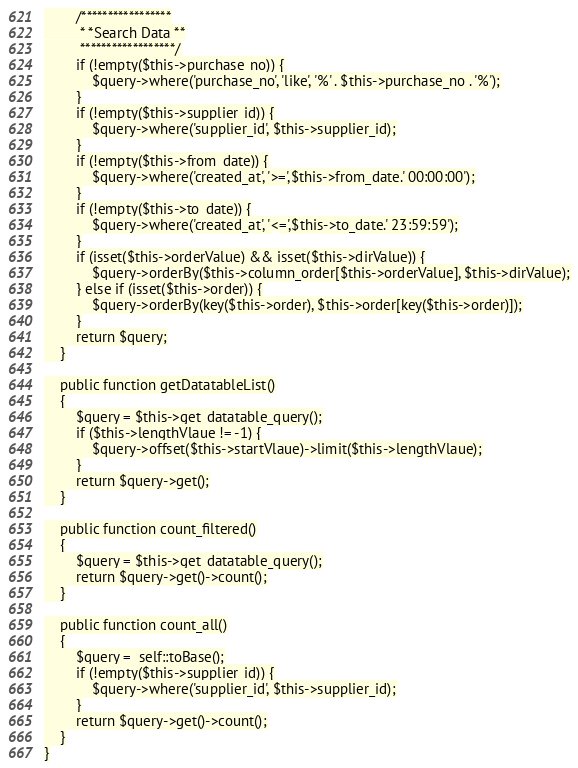<code> <loc_0><loc_0><loc_500><loc_500><_PHP_>        /*****************
         * *Search Data **
         ******************/
        if (!empty($this->purchase_no)) {
            $query->where('purchase_no', 'like', '%' . $this->purchase_no . '%');
        }
        if (!empty($this->supplier_id)) {
            $query->where('supplier_id', $this->supplier_id);
        }
        if (!empty($this->from_date)) {
            $query->where('created_at', '>=',$this->from_date.' 00:00:00');
        }
        if (!empty($this->to_date)) {
            $query->where('created_at', '<=',$this->to_date.' 23:59:59');
        }
        if (isset($this->orderValue) && isset($this->dirValue)) {
            $query->orderBy($this->column_order[$this->orderValue], $this->dirValue);
        } else if (isset($this->order)) {
            $query->orderBy(key($this->order), $this->order[key($this->order)]);
        }
        return $query;
    }

    public function getDatatableList()
    {
        $query = $this->get_datatable_query();
        if ($this->lengthVlaue != -1) {
            $query->offset($this->startVlaue)->limit($this->lengthVlaue);
        }
        return $query->get();
    }

    public function count_filtered()
    {
        $query = $this->get_datatable_query();
        return $query->get()->count();
    }

    public function count_all()
    {
        $query =  self::toBase();
        if (!empty($this->supplier_id)) {
            $query->where('supplier_id', $this->supplier_id);
        }
        return $query->get()->count();
    }
}
</code> 